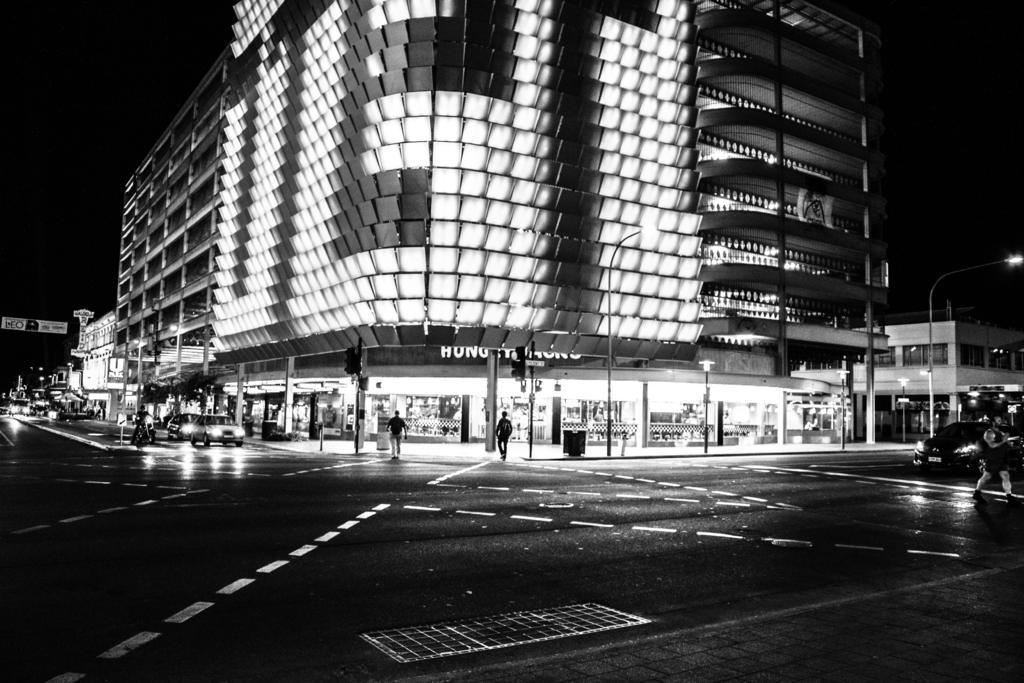Describe this image in one or two sentences. This image consists of a building. At the bottom, there are shops. And we can see many vehicles on the road. On the right, we can see a street light. And there are few persons in this image. 